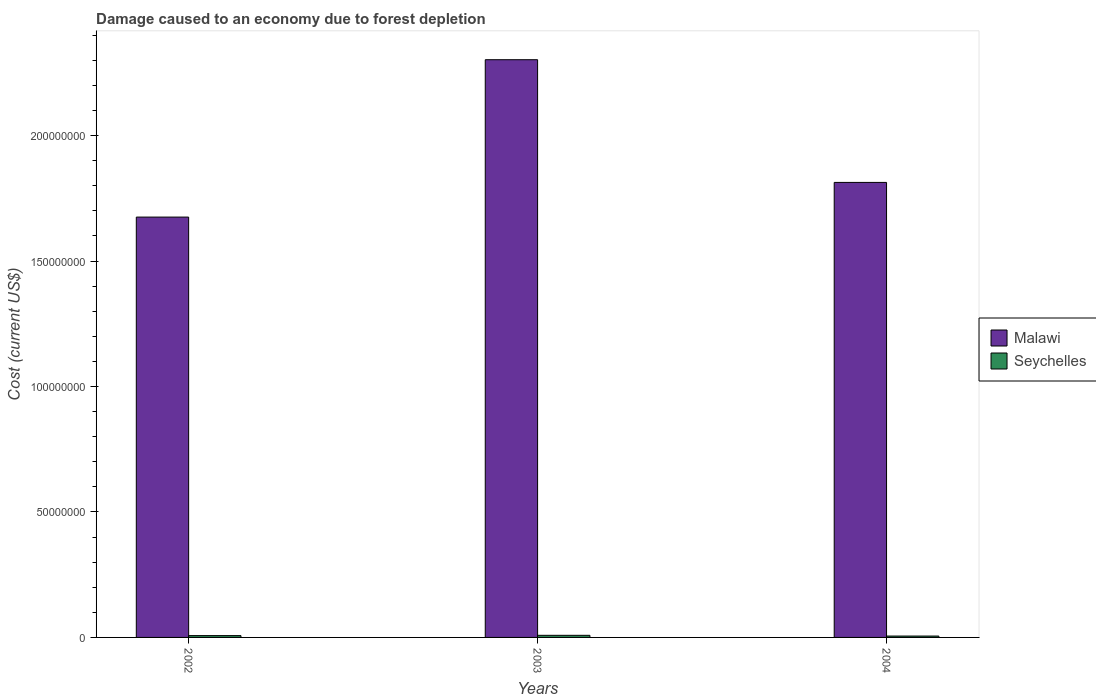How many groups of bars are there?
Your response must be concise. 3. Are the number of bars per tick equal to the number of legend labels?
Your response must be concise. Yes. How many bars are there on the 3rd tick from the right?
Provide a succinct answer. 2. What is the label of the 1st group of bars from the left?
Provide a succinct answer. 2002. What is the cost of damage caused due to forest depletion in Malawi in 2002?
Ensure brevity in your answer.  1.68e+08. Across all years, what is the maximum cost of damage caused due to forest depletion in Seychelles?
Your response must be concise. 8.41e+05. Across all years, what is the minimum cost of damage caused due to forest depletion in Malawi?
Offer a terse response. 1.68e+08. In which year was the cost of damage caused due to forest depletion in Malawi maximum?
Give a very brief answer. 2003. In which year was the cost of damage caused due to forest depletion in Malawi minimum?
Your answer should be compact. 2002. What is the total cost of damage caused due to forest depletion in Seychelles in the graph?
Your answer should be compact. 2.11e+06. What is the difference between the cost of damage caused due to forest depletion in Seychelles in 2003 and that in 2004?
Your answer should be very brief. 2.96e+05. What is the difference between the cost of damage caused due to forest depletion in Seychelles in 2003 and the cost of damage caused due to forest depletion in Malawi in 2002?
Offer a terse response. -1.67e+08. What is the average cost of damage caused due to forest depletion in Seychelles per year?
Provide a short and direct response. 7.04e+05. In the year 2002, what is the difference between the cost of damage caused due to forest depletion in Malawi and cost of damage caused due to forest depletion in Seychelles?
Make the answer very short. 1.67e+08. In how many years, is the cost of damage caused due to forest depletion in Malawi greater than 230000000 US$?
Your answer should be compact. 1. What is the ratio of the cost of damage caused due to forest depletion in Malawi in 2002 to that in 2004?
Offer a very short reply. 0.92. What is the difference between the highest and the second highest cost of damage caused due to forest depletion in Seychelles?
Keep it short and to the point. 1.15e+05. What is the difference between the highest and the lowest cost of damage caused due to forest depletion in Malawi?
Ensure brevity in your answer.  6.27e+07. Is the sum of the cost of damage caused due to forest depletion in Malawi in 2002 and 2004 greater than the maximum cost of damage caused due to forest depletion in Seychelles across all years?
Ensure brevity in your answer.  Yes. What does the 2nd bar from the left in 2002 represents?
Offer a very short reply. Seychelles. What does the 2nd bar from the right in 2004 represents?
Make the answer very short. Malawi. Are the values on the major ticks of Y-axis written in scientific E-notation?
Your response must be concise. No. Does the graph contain any zero values?
Your response must be concise. No. Where does the legend appear in the graph?
Your answer should be compact. Center right. What is the title of the graph?
Offer a very short reply. Damage caused to an economy due to forest depletion. What is the label or title of the X-axis?
Make the answer very short. Years. What is the label or title of the Y-axis?
Your answer should be compact. Cost (current US$). What is the Cost (current US$) of Malawi in 2002?
Ensure brevity in your answer.  1.68e+08. What is the Cost (current US$) in Seychelles in 2002?
Offer a terse response. 7.26e+05. What is the Cost (current US$) of Malawi in 2003?
Make the answer very short. 2.30e+08. What is the Cost (current US$) of Seychelles in 2003?
Give a very brief answer. 8.41e+05. What is the Cost (current US$) of Malawi in 2004?
Your answer should be compact. 1.81e+08. What is the Cost (current US$) of Seychelles in 2004?
Your response must be concise. 5.45e+05. Across all years, what is the maximum Cost (current US$) in Malawi?
Make the answer very short. 2.30e+08. Across all years, what is the maximum Cost (current US$) of Seychelles?
Ensure brevity in your answer.  8.41e+05. Across all years, what is the minimum Cost (current US$) in Malawi?
Offer a very short reply. 1.68e+08. Across all years, what is the minimum Cost (current US$) of Seychelles?
Keep it short and to the point. 5.45e+05. What is the total Cost (current US$) in Malawi in the graph?
Make the answer very short. 5.79e+08. What is the total Cost (current US$) of Seychelles in the graph?
Provide a succinct answer. 2.11e+06. What is the difference between the Cost (current US$) of Malawi in 2002 and that in 2003?
Provide a short and direct response. -6.27e+07. What is the difference between the Cost (current US$) of Seychelles in 2002 and that in 2003?
Give a very brief answer. -1.15e+05. What is the difference between the Cost (current US$) in Malawi in 2002 and that in 2004?
Your answer should be compact. -1.38e+07. What is the difference between the Cost (current US$) in Seychelles in 2002 and that in 2004?
Provide a succinct answer. 1.81e+05. What is the difference between the Cost (current US$) in Malawi in 2003 and that in 2004?
Your answer should be very brief. 4.89e+07. What is the difference between the Cost (current US$) in Seychelles in 2003 and that in 2004?
Provide a succinct answer. 2.96e+05. What is the difference between the Cost (current US$) of Malawi in 2002 and the Cost (current US$) of Seychelles in 2003?
Offer a very short reply. 1.67e+08. What is the difference between the Cost (current US$) in Malawi in 2002 and the Cost (current US$) in Seychelles in 2004?
Give a very brief answer. 1.67e+08. What is the difference between the Cost (current US$) of Malawi in 2003 and the Cost (current US$) of Seychelles in 2004?
Provide a short and direct response. 2.30e+08. What is the average Cost (current US$) in Malawi per year?
Your response must be concise. 1.93e+08. What is the average Cost (current US$) of Seychelles per year?
Your answer should be compact. 7.04e+05. In the year 2002, what is the difference between the Cost (current US$) of Malawi and Cost (current US$) of Seychelles?
Your answer should be very brief. 1.67e+08. In the year 2003, what is the difference between the Cost (current US$) in Malawi and Cost (current US$) in Seychelles?
Your answer should be compact. 2.29e+08. In the year 2004, what is the difference between the Cost (current US$) in Malawi and Cost (current US$) in Seychelles?
Provide a short and direct response. 1.81e+08. What is the ratio of the Cost (current US$) in Malawi in 2002 to that in 2003?
Your answer should be compact. 0.73. What is the ratio of the Cost (current US$) of Seychelles in 2002 to that in 2003?
Your answer should be compact. 0.86. What is the ratio of the Cost (current US$) in Malawi in 2002 to that in 2004?
Your response must be concise. 0.92. What is the ratio of the Cost (current US$) in Seychelles in 2002 to that in 2004?
Provide a short and direct response. 1.33. What is the ratio of the Cost (current US$) of Malawi in 2003 to that in 2004?
Make the answer very short. 1.27. What is the ratio of the Cost (current US$) of Seychelles in 2003 to that in 2004?
Make the answer very short. 1.54. What is the difference between the highest and the second highest Cost (current US$) in Malawi?
Make the answer very short. 4.89e+07. What is the difference between the highest and the second highest Cost (current US$) in Seychelles?
Your answer should be compact. 1.15e+05. What is the difference between the highest and the lowest Cost (current US$) of Malawi?
Offer a very short reply. 6.27e+07. What is the difference between the highest and the lowest Cost (current US$) of Seychelles?
Provide a short and direct response. 2.96e+05. 